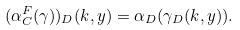Convert formula to latex. <formula><loc_0><loc_0><loc_500><loc_500>( \alpha _ { C } ^ { F } ( \gamma ) ) _ { D } ( k , y ) = \alpha _ { D } ( \gamma _ { D } ( k , y ) ) .</formula> 